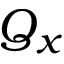<formula> <loc_0><loc_0><loc_500><loc_500>Q _ { x }</formula> 